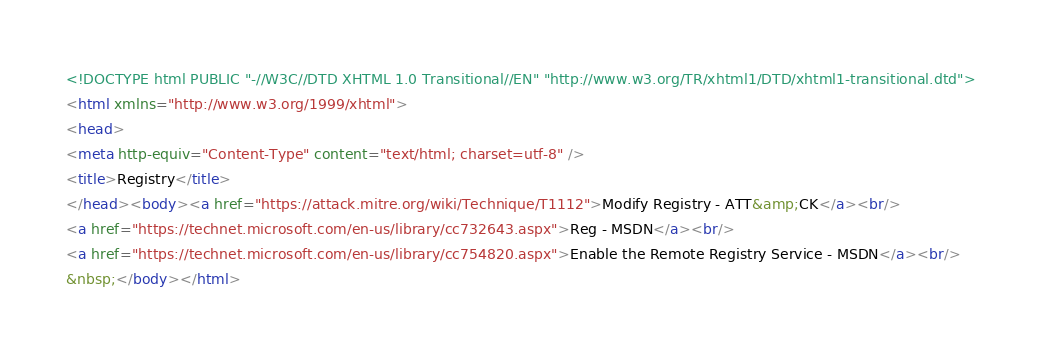Convert code to text. <code><loc_0><loc_0><loc_500><loc_500><_HTML_><!DOCTYPE html PUBLIC "-//W3C//DTD XHTML 1.0 Transitional//EN" "http://www.w3.org/TR/xhtml1/DTD/xhtml1-transitional.dtd">
<html xmlns="http://www.w3.org/1999/xhtml">
<head>
<meta http-equiv="Content-Type" content="text/html; charset=utf-8" />
<title>Registry</title>
</head><body><a href="https://attack.mitre.org/wiki/Technique/T1112">Modify Registry - ATT&amp;CK</a><br/>
<a href="https://technet.microsoft.com/en-us/library/cc732643.aspx">Reg - MSDN</a><br/>
<a href="https://technet.microsoft.com/en-us/library/cc754820.aspx">Enable the Remote Registry Service - MSDN</a><br/>
&nbsp;</body></html></code> 